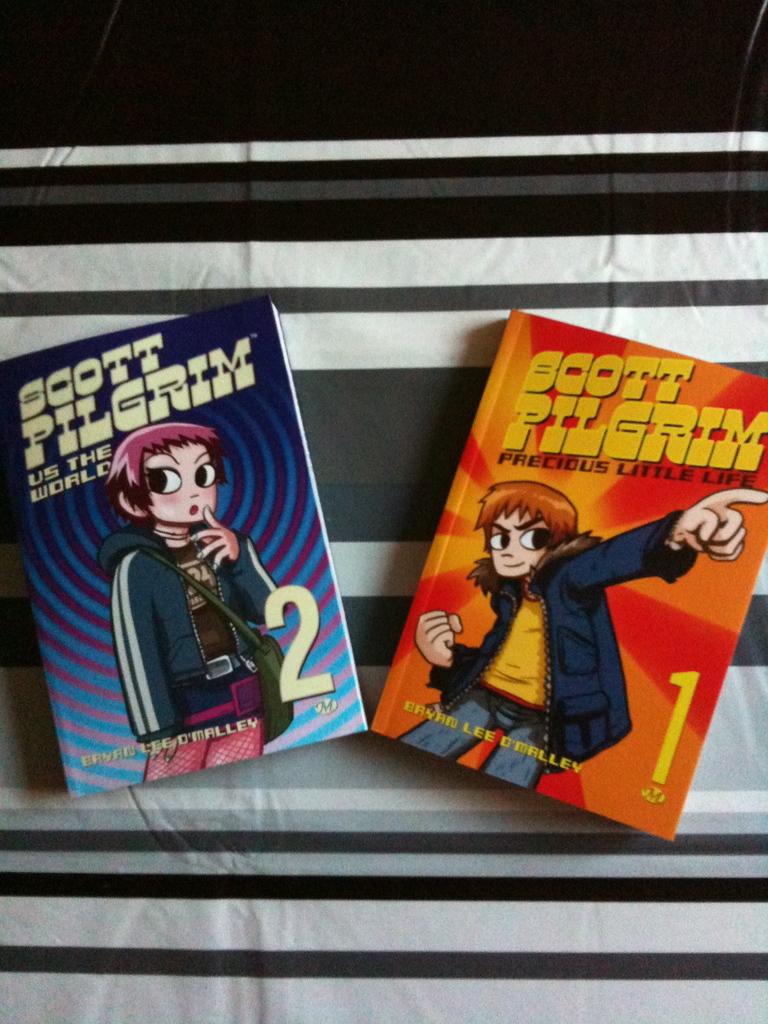Who is the author of these books?
Ensure brevity in your answer.  Bryan lee o'malley. 